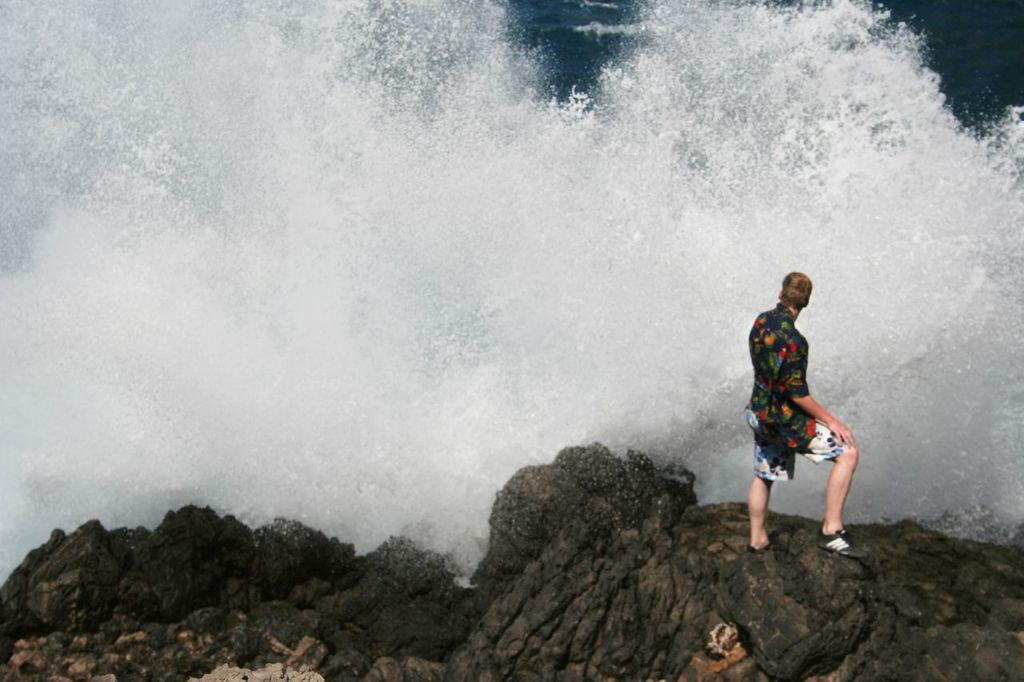What is the main subject in the image? There is a person standing in the image. What can be seen at the bottom of the image? There are rocks at the bottom of the image. What is visible in the background of the image? There is water visible in the background of the image. What type of steel is being used to construct the mouth of the person in the image? There is no mention of steel or a mouth in the image; the person is simply standing. 